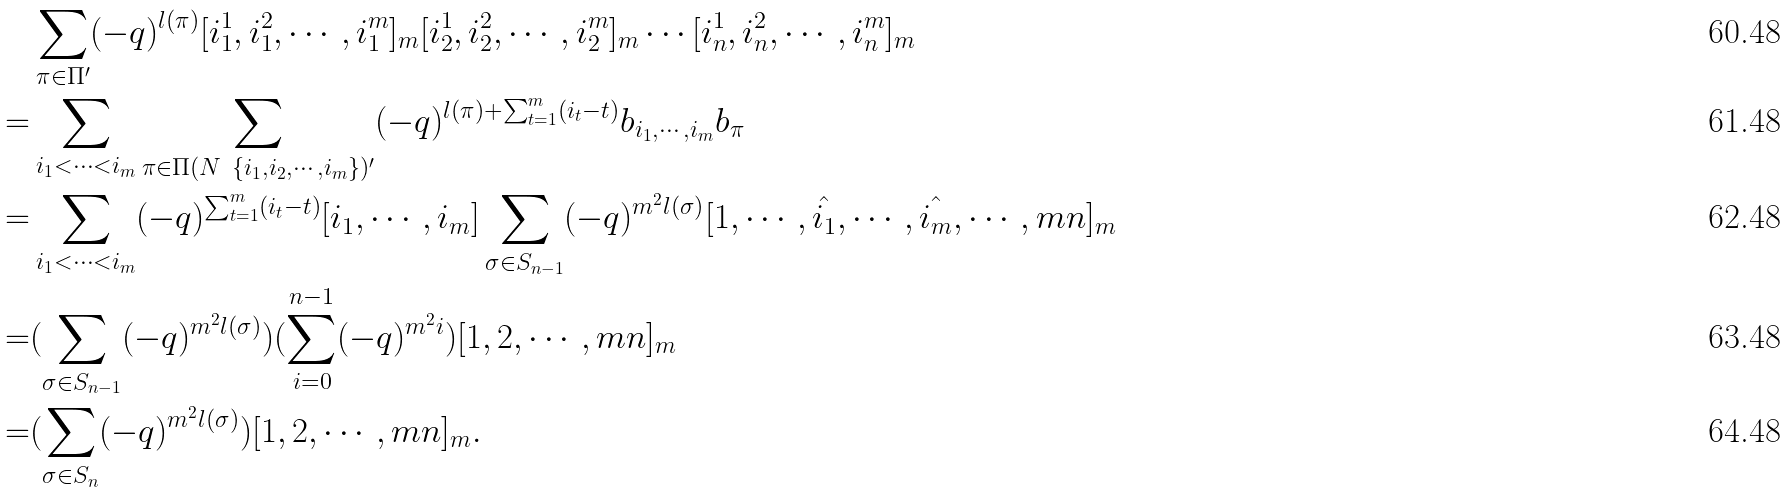<formula> <loc_0><loc_0><loc_500><loc_500>& \sum _ { \pi \in \Pi ^ { \prime } } ( - q ) ^ { l ( \pi ) } [ i _ { 1 } ^ { 1 } , i _ { 1 } ^ { 2 } , \cdots , i _ { 1 } ^ { m } ] _ { m } [ i _ { 2 } ^ { 1 } , i _ { 2 } ^ { 2 } , \cdots , i _ { 2 } ^ { m } ] _ { m } \cdots [ i _ { n } ^ { 1 } , i _ { n } ^ { 2 } , \cdots , i _ { n } ^ { m } ] _ { m } \\ = & \sum _ { i _ { 1 } < \cdots < i _ { m } } \sum _ { \pi \in \Pi ( N \ \{ i _ { 1 } , i _ { 2 } , \cdots , i _ { m } \} ) ^ { \prime } } ( - q ) ^ { l ( \pi ) + \sum _ { t = 1 } ^ { m } ( i _ { t } - t ) } b _ { i _ { 1 } , \cdots , i _ { m } } b _ { \pi } \\ = & \sum _ { i _ { 1 } < \cdots < i _ { m } } ( - q ) ^ { \sum _ { t = 1 } ^ { m } ( i _ { t } - t ) } [ i _ { 1 } , \cdots , i _ { m } ] \sum _ { \sigma \in S _ { n - 1 } } ( - q ) ^ { m ^ { 2 } l ( \sigma ) } [ 1 , \cdots , \hat { i _ { 1 } } , \cdots , \hat { i _ { m } } , \cdots , m n ] _ { m } \\ = & ( \sum _ { \sigma \in S _ { n - 1 } } ( - q ) ^ { m ^ { 2 } l ( \sigma ) } ) ( \sum _ { i = 0 } ^ { n - 1 } ( - q ) ^ { m ^ { 2 } i } ) [ 1 , 2 , \cdots , m n ] _ { m } \\ = & ( \sum _ { \sigma \in S _ { n } } ( - q ) ^ { m ^ { 2 } l ( \sigma ) } ) [ 1 , 2 , \cdots , m n ] _ { m } .</formula> 